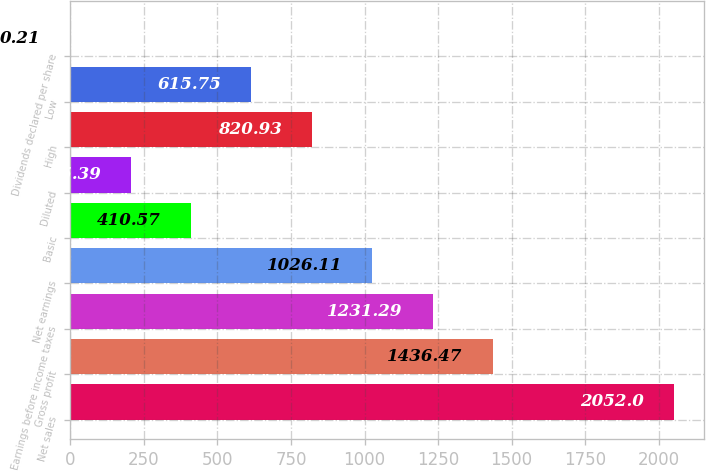Convert chart to OTSL. <chart><loc_0><loc_0><loc_500><loc_500><bar_chart><fcel>Net sales<fcel>Gross profit<fcel>Earnings before income taxes<fcel>Net earnings<fcel>Basic<fcel>Diluted<fcel>High<fcel>Low<fcel>Dividends declared per share<nl><fcel>2052<fcel>1436.47<fcel>1231.29<fcel>1026.11<fcel>410.57<fcel>205.39<fcel>820.93<fcel>615.75<fcel>0.21<nl></chart> 